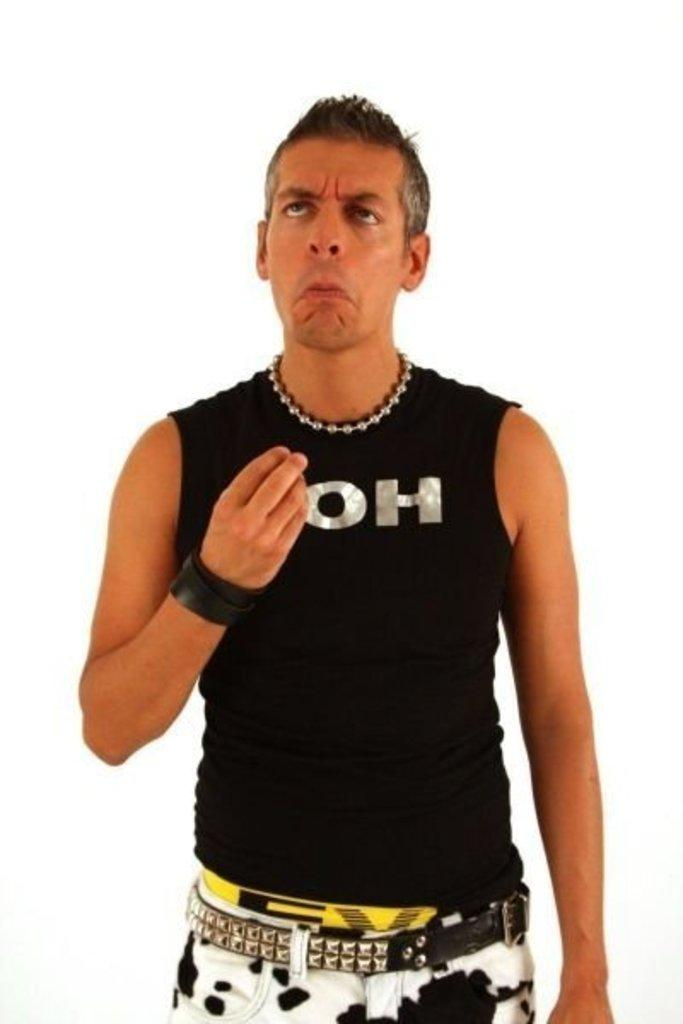<image>
Give a short and clear explanation of the subsequent image. Man wearing a black sleeveless shirt that says OH on it. 